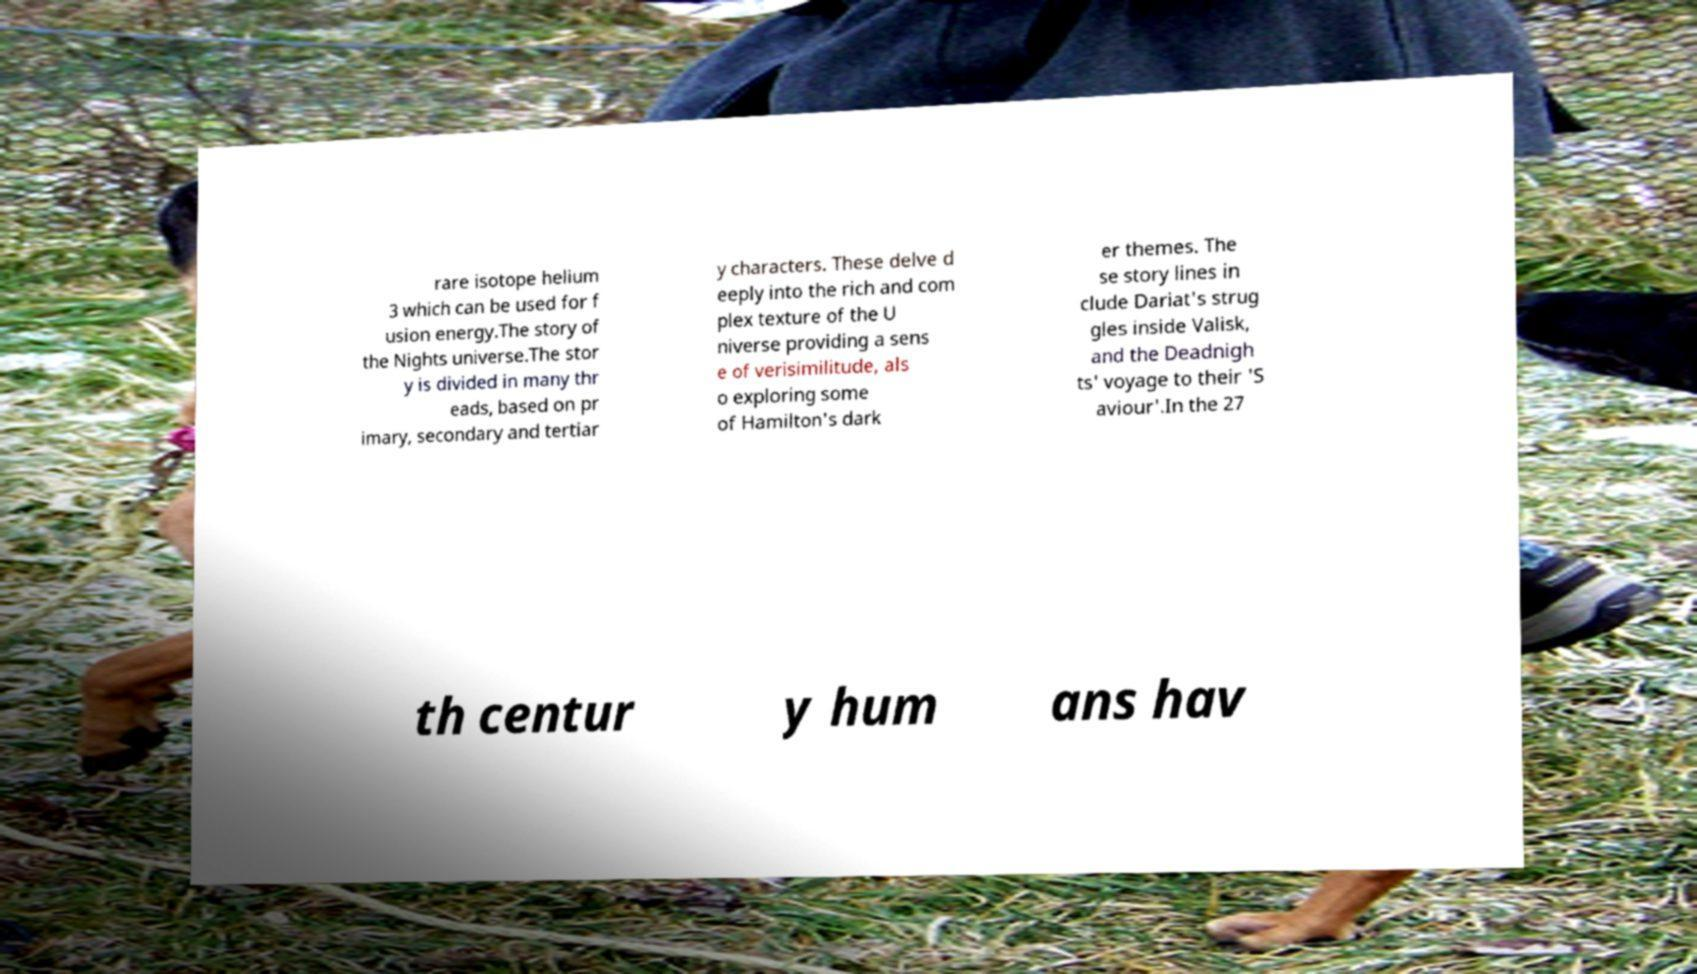Could you assist in decoding the text presented in this image and type it out clearly? rare isotope helium 3 which can be used for f usion energy.The story of the Nights universe.The stor y is divided in many thr eads, based on pr imary, secondary and tertiar y characters. These delve d eeply into the rich and com plex texture of the U niverse providing a sens e of verisimilitude, als o exploring some of Hamilton's dark er themes. The se story lines in clude Dariat's strug gles inside Valisk, and the Deadnigh ts' voyage to their 'S aviour'.In the 27 th centur y hum ans hav 